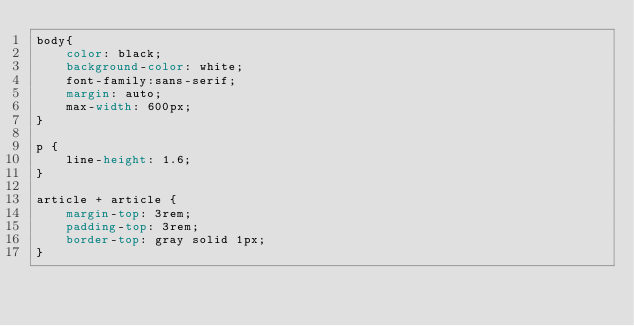Convert code to text. <code><loc_0><loc_0><loc_500><loc_500><_CSS_>body{
    color: black;
    background-color: white;
    font-family:sans-serif;
    margin: auto;
    max-width: 600px;
}

p {
    line-height: 1.6;
}

article + article {
    margin-top: 3rem;
    padding-top: 3rem;
    border-top: gray solid 1px;
}
</code> 